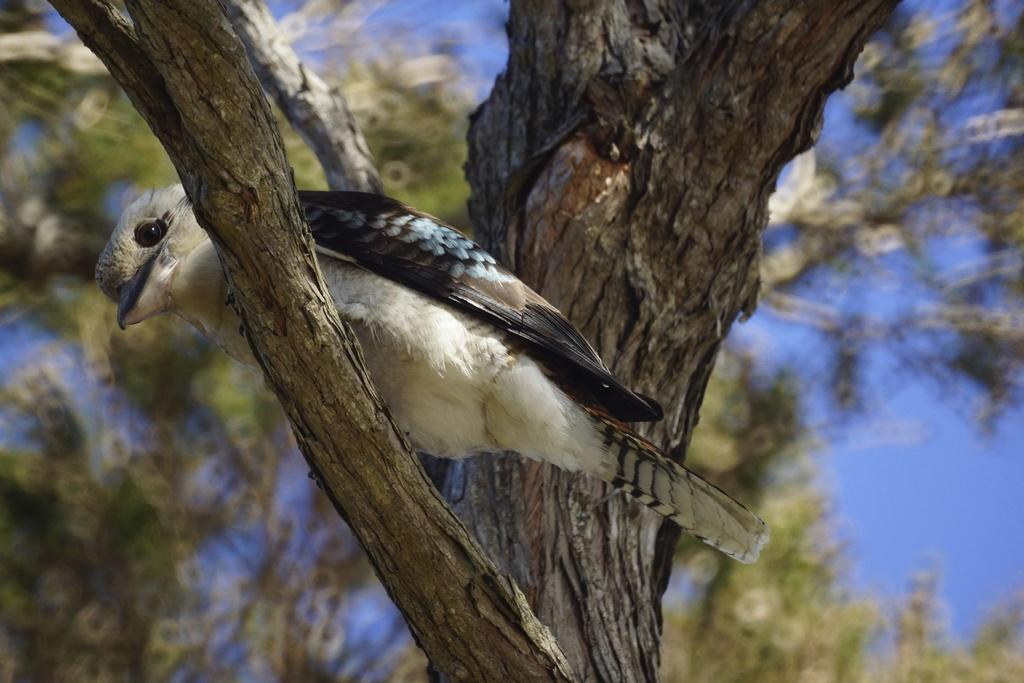What type of animal can be seen in the image? There is a bird in the image. Where is the bird located? The bird is on a branch of a tree. What can be seen in the background of the image? The background of the image is blurry, and there are branches of trees and the sky visible. What type of education does the bird have in the image? There is no indication of the bird's education in the image. How many knots are visible on the branch where the bird is sitting? There is no mention of knots on the branch in the image. 